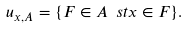<formula> <loc_0><loc_0><loc_500><loc_500>u _ { x , A } = \{ F \in A \ s t x \in F \} .</formula> 